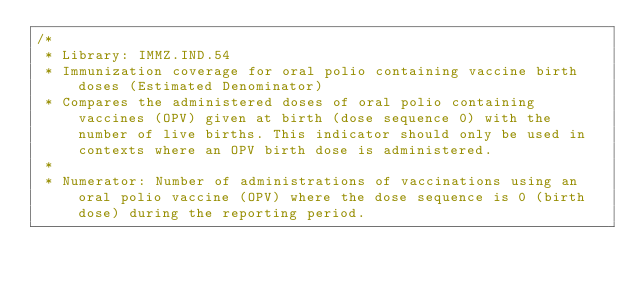Convert code to text. <code><loc_0><loc_0><loc_500><loc_500><_SQL_>/*
 * Library: IMMZ.IND.54
 * Immunization coverage for oral polio containing vaccine birth doses (Estimated Denominator) 
 * Compares the administered doses of oral polio containing vaccines (OPV) given at birth (dose sequence 0) with the number of live births. This indicator should only be used in contexts where an OPV birth dose is administered.
 * 
 * Numerator: Number of administrations of vaccinations using an oral polio vaccine (OPV) where the dose sequence is 0 (birth dose) during the reporting period. </code> 